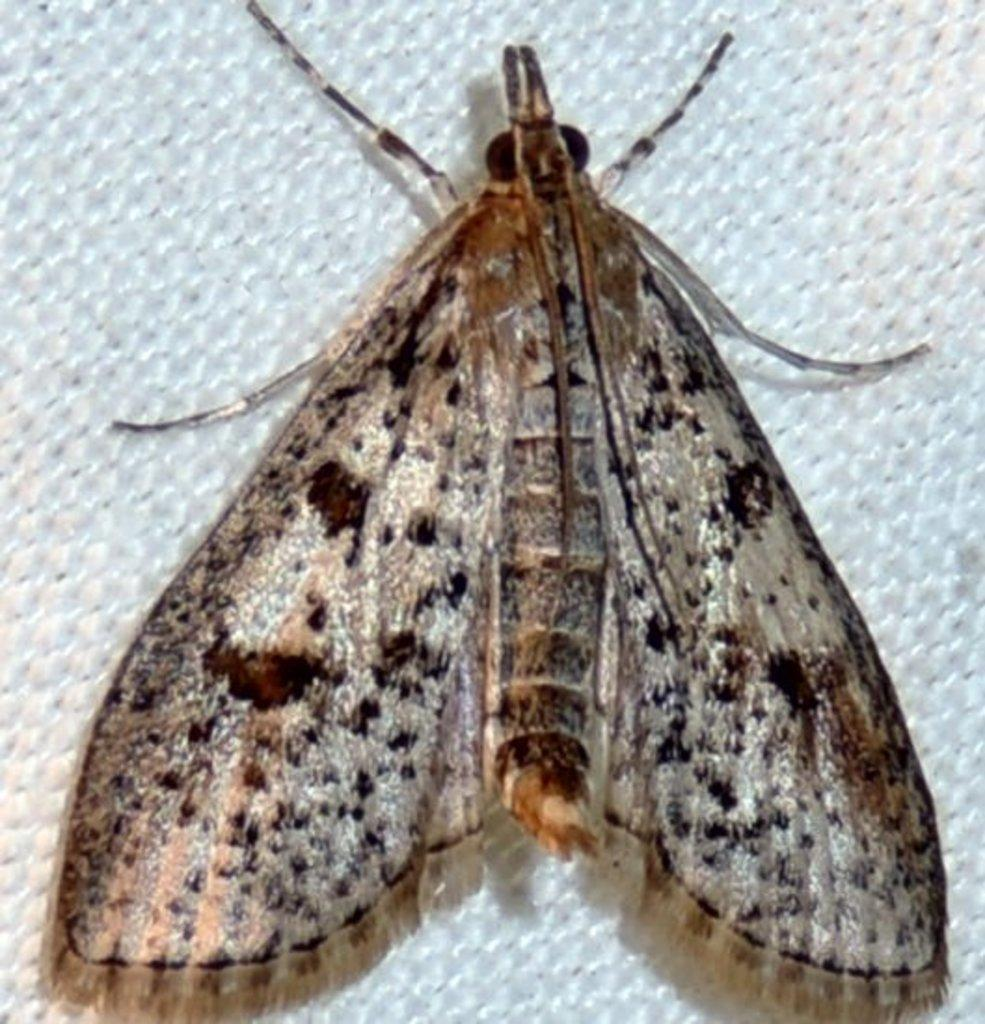What type of creature can be seen in the image? There is an insect in the image. What color is the background of the image? The background of the image is white. What type of advice does the grandfather give to the insect in the image? There is no grandfather present in the image, and therefore no advice can be given. What type of clam can be seen in the image? There is no clam present in the image. 